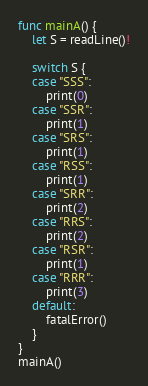Convert code to text. <code><loc_0><loc_0><loc_500><loc_500><_Swift_>func mainA() {
    let S = readLine()!

    switch S {
    case "SSS":
        print(0)
    case "SSR":
        print(1)
    case "SRS":
        print(1)
    case "RSS":
        print(1)
    case "SRR":
        print(2)
    case "RRS":
        print(2)
    case "RSR":
        print(1)
    case "RRR":
        print(3)
    default:
        fatalError()
    }
}
mainA()</code> 